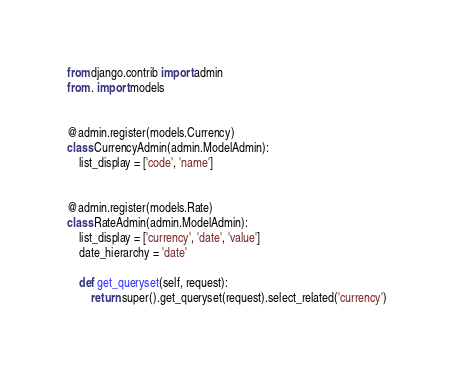<code> <loc_0><loc_0><loc_500><loc_500><_Python_>from django.contrib import admin
from . import models


@admin.register(models.Currency)
class CurrencyAdmin(admin.ModelAdmin):
    list_display = ['code', 'name']


@admin.register(models.Rate)
class RateAdmin(admin.ModelAdmin):
    list_display = ['currency', 'date', 'value']
    date_hierarchy = 'date'

    def get_queryset(self, request):
        return super().get_queryset(request).select_related('currency')
</code> 